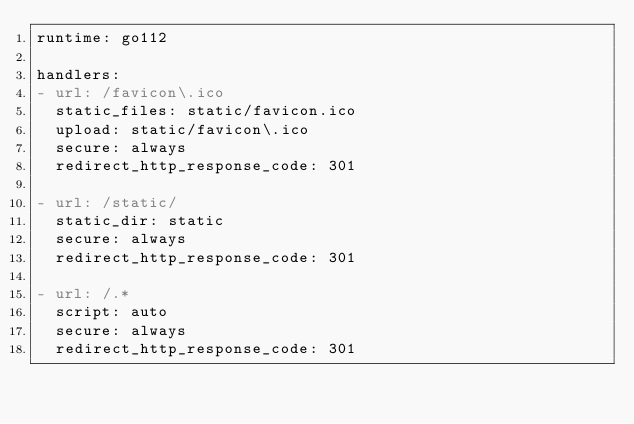Convert code to text. <code><loc_0><loc_0><loc_500><loc_500><_YAML_>runtime: go112

handlers:
- url: /favicon\.ico
  static_files: static/favicon.ico
  upload: static/favicon\.ico
  secure: always
  redirect_http_response_code: 301

- url: /static/
  static_dir: static
  secure: always
  redirect_http_response_code: 301

- url: /.*
  script: auto
  secure: always
  redirect_http_response_code: 301


</code> 